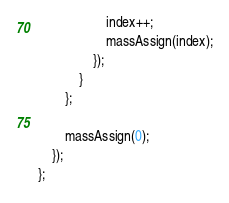Convert code to text. <code><loc_0><loc_0><loc_500><loc_500><_JavaScript_>                    index++;
                    massAssign(index);
                });
            }
        };

        massAssign(0);
    });
};
</code> 